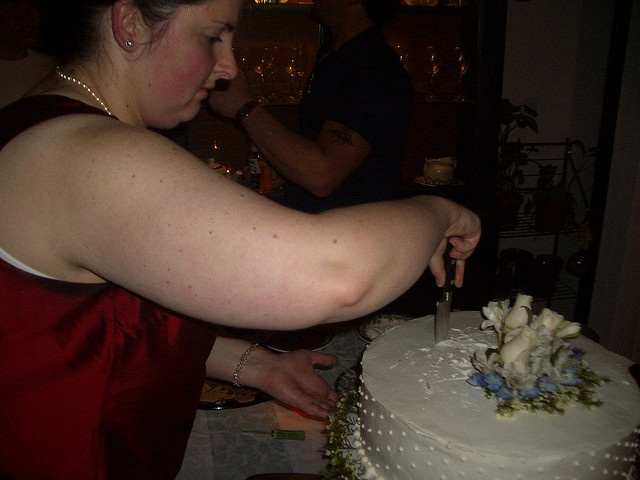Describe the objects in this image and their specific colors. I can see people in black, gray, and maroon tones, cake in black and gray tones, people in black, maroon, and gray tones, dining table in black, maroon, and gray tones, and wine glass in black, maroon, and brown tones in this image. 